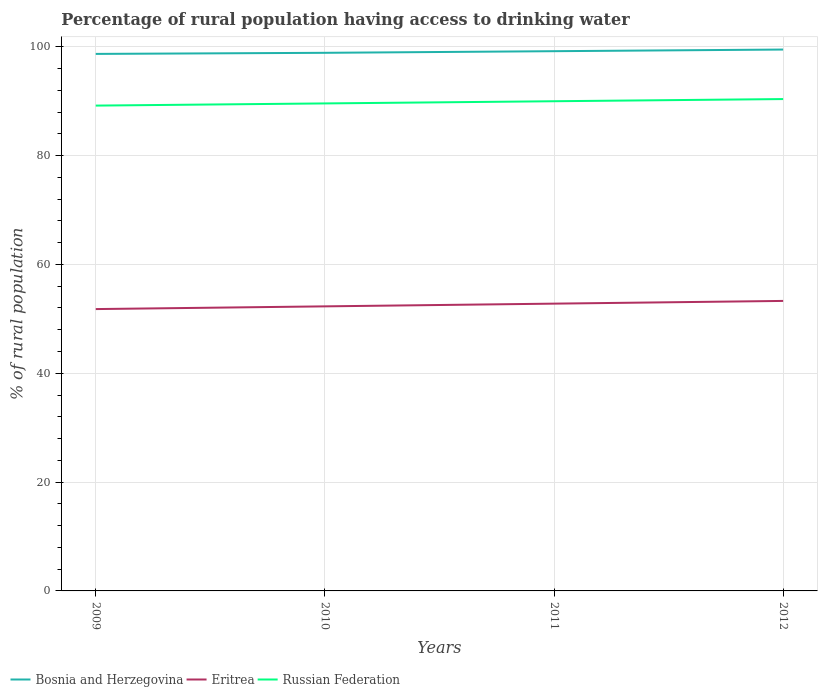How many different coloured lines are there?
Make the answer very short. 3. Does the line corresponding to Russian Federation intersect with the line corresponding to Eritrea?
Make the answer very short. No. Across all years, what is the maximum percentage of rural population having access to drinking water in Bosnia and Herzegovina?
Provide a short and direct response. 98.7. In which year was the percentage of rural population having access to drinking water in Russian Federation maximum?
Offer a terse response. 2009. What is the total percentage of rural population having access to drinking water in Bosnia and Herzegovina in the graph?
Keep it short and to the point. -0.3. What is the difference between the highest and the second highest percentage of rural population having access to drinking water in Russian Federation?
Give a very brief answer. 1.2. How many lines are there?
Offer a terse response. 3. How many years are there in the graph?
Ensure brevity in your answer.  4. Are the values on the major ticks of Y-axis written in scientific E-notation?
Make the answer very short. No. Does the graph contain any zero values?
Make the answer very short. No. Where does the legend appear in the graph?
Keep it short and to the point. Bottom left. How many legend labels are there?
Make the answer very short. 3. How are the legend labels stacked?
Your answer should be very brief. Horizontal. What is the title of the graph?
Make the answer very short. Percentage of rural population having access to drinking water. Does "Macedonia" appear as one of the legend labels in the graph?
Make the answer very short. No. What is the label or title of the X-axis?
Provide a succinct answer. Years. What is the label or title of the Y-axis?
Your answer should be compact. % of rural population. What is the % of rural population in Bosnia and Herzegovina in 2009?
Provide a succinct answer. 98.7. What is the % of rural population of Eritrea in 2009?
Provide a short and direct response. 51.8. What is the % of rural population in Russian Federation in 2009?
Offer a terse response. 89.2. What is the % of rural population in Bosnia and Herzegovina in 2010?
Provide a short and direct response. 98.9. What is the % of rural population of Eritrea in 2010?
Make the answer very short. 52.3. What is the % of rural population in Russian Federation in 2010?
Give a very brief answer. 89.6. What is the % of rural population of Bosnia and Herzegovina in 2011?
Keep it short and to the point. 99.2. What is the % of rural population of Eritrea in 2011?
Ensure brevity in your answer.  52.8. What is the % of rural population in Bosnia and Herzegovina in 2012?
Offer a very short reply. 99.5. What is the % of rural population in Eritrea in 2012?
Your response must be concise. 53.3. What is the % of rural population in Russian Federation in 2012?
Provide a succinct answer. 90.4. Across all years, what is the maximum % of rural population in Bosnia and Herzegovina?
Offer a terse response. 99.5. Across all years, what is the maximum % of rural population of Eritrea?
Your answer should be compact. 53.3. Across all years, what is the maximum % of rural population in Russian Federation?
Your answer should be compact. 90.4. Across all years, what is the minimum % of rural population in Bosnia and Herzegovina?
Your answer should be compact. 98.7. Across all years, what is the minimum % of rural population in Eritrea?
Your answer should be compact. 51.8. Across all years, what is the minimum % of rural population of Russian Federation?
Offer a terse response. 89.2. What is the total % of rural population of Bosnia and Herzegovina in the graph?
Provide a succinct answer. 396.3. What is the total % of rural population in Eritrea in the graph?
Make the answer very short. 210.2. What is the total % of rural population of Russian Federation in the graph?
Keep it short and to the point. 359.2. What is the difference between the % of rural population in Bosnia and Herzegovina in 2009 and that in 2010?
Offer a very short reply. -0.2. What is the difference between the % of rural population of Eritrea in 2009 and that in 2010?
Provide a short and direct response. -0.5. What is the difference between the % of rural population of Russian Federation in 2009 and that in 2010?
Your response must be concise. -0.4. What is the difference between the % of rural population in Russian Federation in 2009 and that in 2011?
Provide a short and direct response. -0.8. What is the difference between the % of rural population of Bosnia and Herzegovina in 2009 and that in 2012?
Offer a very short reply. -0.8. What is the difference between the % of rural population in Eritrea in 2009 and that in 2012?
Provide a succinct answer. -1.5. What is the difference between the % of rural population in Russian Federation in 2009 and that in 2012?
Provide a short and direct response. -1.2. What is the difference between the % of rural population of Bosnia and Herzegovina in 2010 and that in 2011?
Provide a succinct answer. -0.3. What is the difference between the % of rural population of Russian Federation in 2010 and that in 2011?
Offer a very short reply. -0.4. What is the difference between the % of rural population of Russian Federation in 2011 and that in 2012?
Give a very brief answer. -0.4. What is the difference between the % of rural population in Bosnia and Herzegovina in 2009 and the % of rural population in Eritrea in 2010?
Your answer should be very brief. 46.4. What is the difference between the % of rural population of Eritrea in 2009 and the % of rural population of Russian Federation in 2010?
Offer a terse response. -37.8. What is the difference between the % of rural population of Bosnia and Herzegovina in 2009 and the % of rural population of Eritrea in 2011?
Ensure brevity in your answer.  45.9. What is the difference between the % of rural population in Bosnia and Herzegovina in 2009 and the % of rural population in Russian Federation in 2011?
Your answer should be compact. 8.7. What is the difference between the % of rural population in Eritrea in 2009 and the % of rural population in Russian Federation in 2011?
Your answer should be compact. -38.2. What is the difference between the % of rural population in Bosnia and Herzegovina in 2009 and the % of rural population in Eritrea in 2012?
Offer a very short reply. 45.4. What is the difference between the % of rural population of Bosnia and Herzegovina in 2009 and the % of rural population of Russian Federation in 2012?
Offer a terse response. 8.3. What is the difference between the % of rural population of Eritrea in 2009 and the % of rural population of Russian Federation in 2012?
Keep it short and to the point. -38.6. What is the difference between the % of rural population of Bosnia and Herzegovina in 2010 and the % of rural population of Eritrea in 2011?
Provide a short and direct response. 46.1. What is the difference between the % of rural population of Eritrea in 2010 and the % of rural population of Russian Federation in 2011?
Make the answer very short. -37.7. What is the difference between the % of rural population of Bosnia and Herzegovina in 2010 and the % of rural population of Eritrea in 2012?
Offer a very short reply. 45.6. What is the difference between the % of rural population in Bosnia and Herzegovina in 2010 and the % of rural population in Russian Federation in 2012?
Your response must be concise. 8.5. What is the difference between the % of rural population of Eritrea in 2010 and the % of rural population of Russian Federation in 2012?
Make the answer very short. -38.1. What is the difference between the % of rural population in Bosnia and Herzegovina in 2011 and the % of rural population in Eritrea in 2012?
Offer a terse response. 45.9. What is the difference between the % of rural population of Eritrea in 2011 and the % of rural population of Russian Federation in 2012?
Give a very brief answer. -37.6. What is the average % of rural population of Bosnia and Herzegovina per year?
Provide a succinct answer. 99.08. What is the average % of rural population in Eritrea per year?
Your answer should be very brief. 52.55. What is the average % of rural population in Russian Federation per year?
Your response must be concise. 89.8. In the year 2009, what is the difference between the % of rural population of Bosnia and Herzegovina and % of rural population of Eritrea?
Your answer should be compact. 46.9. In the year 2009, what is the difference between the % of rural population of Bosnia and Herzegovina and % of rural population of Russian Federation?
Ensure brevity in your answer.  9.5. In the year 2009, what is the difference between the % of rural population of Eritrea and % of rural population of Russian Federation?
Offer a very short reply. -37.4. In the year 2010, what is the difference between the % of rural population in Bosnia and Herzegovina and % of rural population in Eritrea?
Give a very brief answer. 46.6. In the year 2010, what is the difference between the % of rural population of Eritrea and % of rural population of Russian Federation?
Offer a very short reply. -37.3. In the year 2011, what is the difference between the % of rural population of Bosnia and Herzegovina and % of rural population of Eritrea?
Your response must be concise. 46.4. In the year 2011, what is the difference between the % of rural population in Eritrea and % of rural population in Russian Federation?
Your answer should be compact. -37.2. In the year 2012, what is the difference between the % of rural population of Bosnia and Herzegovina and % of rural population of Eritrea?
Your answer should be very brief. 46.2. In the year 2012, what is the difference between the % of rural population of Bosnia and Herzegovina and % of rural population of Russian Federation?
Your answer should be compact. 9.1. In the year 2012, what is the difference between the % of rural population of Eritrea and % of rural population of Russian Federation?
Your answer should be very brief. -37.1. What is the ratio of the % of rural population of Eritrea in 2009 to that in 2011?
Your answer should be compact. 0.98. What is the ratio of the % of rural population in Russian Federation in 2009 to that in 2011?
Ensure brevity in your answer.  0.99. What is the ratio of the % of rural population in Bosnia and Herzegovina in 2009 to that in 2012?
Make the answer very short. 0.99. What is the ratio of the % of rural population in Eritrea in 2009 to that in 2012?
Ensure brevity in your answer.  0.97. What is the ratio of the % of rural population of Russian Federation in 2009 to that in 2012?
Offer a terse response. 0.99. What is the ratio of the % of rural population of Bosnia and Herzegovina in 2010 to that in 2012?
Your response must be concise. 0.99. What is the ratio of the % of rural population of Eritrea in 2010 to that in 2012?
Your answer should be very brief. 0.98. What is the ratio of the % of rural population of Russian Federation in 2010 to that in 2012?
Provide a succinct answer. 0.99. What is the ratio of the % of rural population in Bosnia and Herzegovina in 2011 to that in 2012?
Your answer should be compact. 1. What is the ratio of the % of rural population of Eritrea in 2011 to that in 2012?
Provide a short and direct response. 0.99. What is the difference between the highest and the second highest % of rural population of Eritrea?
Your response must be concise. 0.5. What is the difference between the highest and the lowest % of rural population in Russian Federation?
Keep it short and to the point. 1.2. 